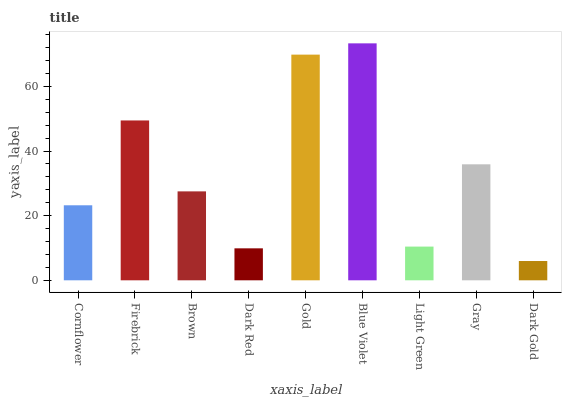Is Dark Gold the minimum?
Answer yes or no. Yes. Is Blue Violet the maximum?
Answer yes or no. Yes. Is Firebrick the minimum?
Answer yes or no. No. Is Firebrick the maximum?
Answer yes or no. No. Is Firebrick greater than Cornflower?
Answer yes or no. Yes. Is Cornflower less than Firebrick?
Answer yes or no. Yes. Is Cornflower greater than Firebrick?
Answer yes or no. No. Is Firebrick less than Cornflower?
Answer yes or no. No. Is Brown the high median?
Answer yes or no. Yes. Is Brown the low median?
Answer yes or no. Yes. Is Gray the high median?
Answer yes or no. No. Is Dark Gold the low median?
Answer yes or no. No. 